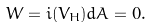<formula> <loc_0><loc_0><loc_500><loc_500>W = i ( V _ { H } ) d A = 0 .</formula> 